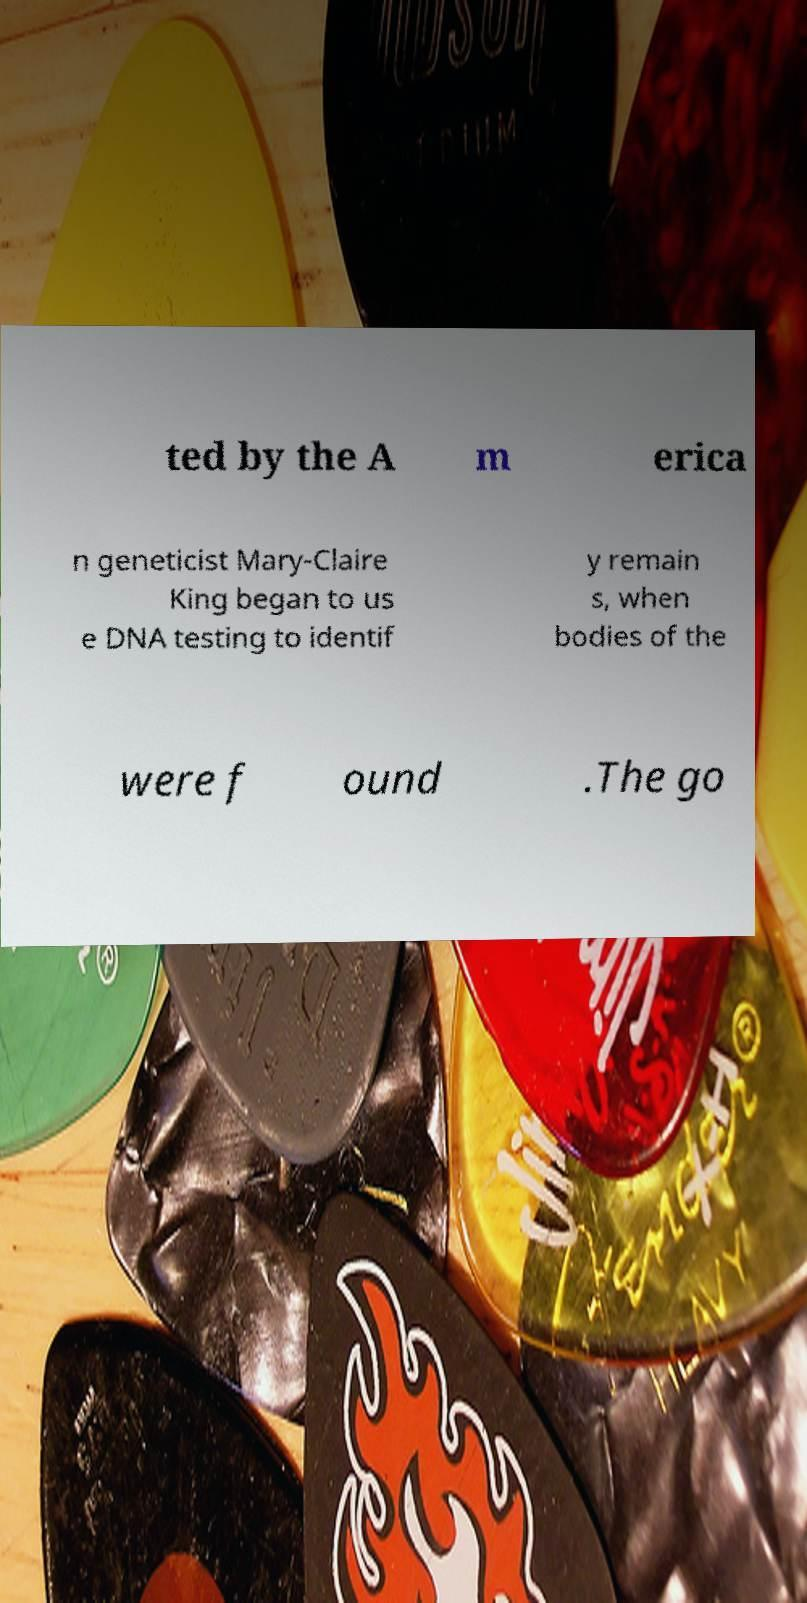For documentation purposes, I need the text within this image transcribed. Could you provide that? ted by the A m erica n geneticist Mary-Claire King began to us e DNA testing to identif y remain s, when bodies of the were f ound .The go 